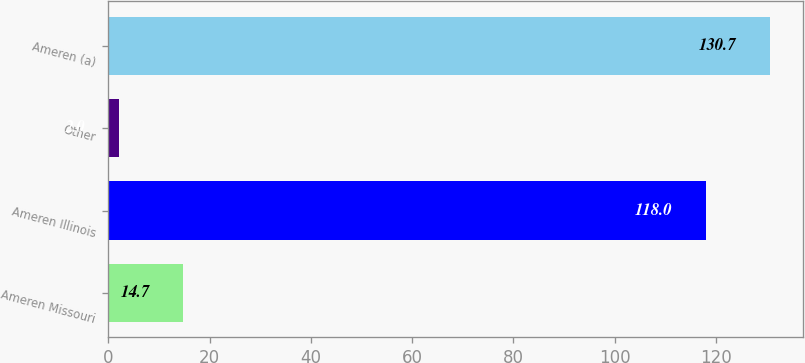Convert chart to OTSL. <chart><loc_0><loc_0><loc_500><loc_500><bar_chart><fcel>Ameren Missouri<fcel>Ameren Illinois<fcel>Other<fcel>Ameren (a)<nl><fcel>14.7<fcel>118<fcel>2<fcel>130.7<nl></chart> 